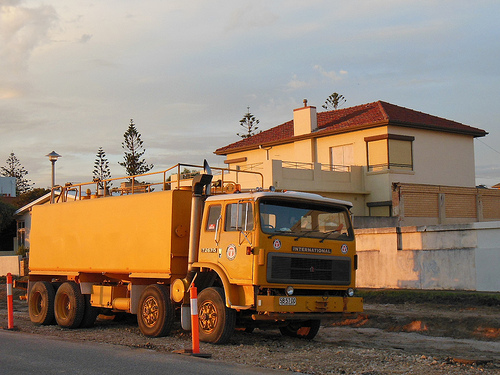Please provide a description for the region specified [0.26, 0.7, 0.34, 0.8]. Visible in this section is a truck's wheel, prominently featuring a robust tire mounted on what appears to be a very solid wheel frame intended for heavy loads. 